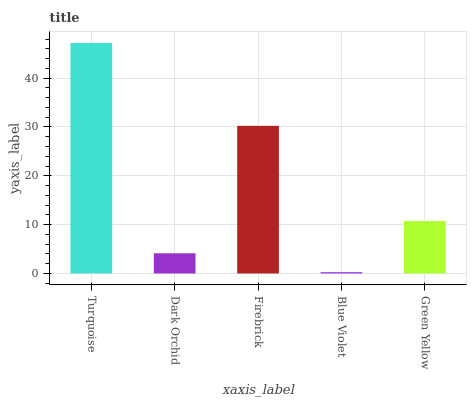Is Blue Violet the minimum?
Answer yes or no. Yes. Is Turquoise the maximum?
Answer yes or no. Yes. Is Dark Orchid the minimum?
Answer yes or no. No. Is Dark Orchid the maximum?
Answer yes or no. No. Is Turquoise greater than Dark Orchid?
Answer yes or no. Yes. Is Dark Orchid less than Turquoise?
Answer yes or no. Yes. Is Dark Orchid greater than Turquoise?
Answer yes or no. No. Is Turquoise less than Dark Orchid?
Answer yes or no. No. Is Green Yellow the high median?
Answer yes or no. Yes. Is Green Yellow the low median?
Answer yes or no. Yes. Is Blue Violet the high median?
Answer yes or no. No. Is Firebrick the low median?
Answer yes or no. No. 